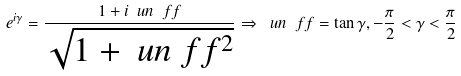Convert formula to latex. <formula><loc_0><loc_0><loc_500><loc_500>e ^ { i \gamma } = \frac { 1 + i \ u n \ f f } { \sqrt { 1 + \ u n \ f f ^ { 2 } } } \Rightarrow \ u n \ f f = \tan \gamma , - \frac { \pi } { 2 } < \gamma < \frac { \pi } { 2 }</formula> 